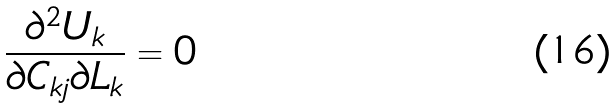<formula> <loc_0><loc_0><loc_500><loc_500>\frac { \partial ^ { 2 } U _ { k } } { \partial C _ { k j } \partial L _ { k } } = 0</formula> 